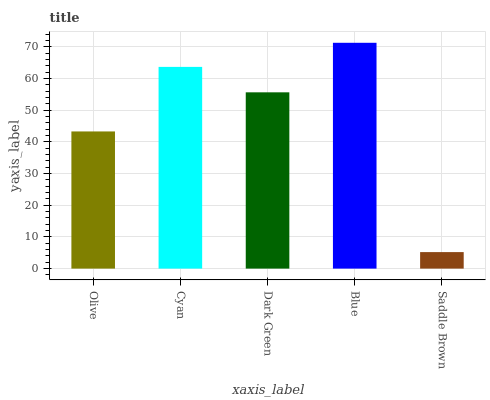Is Saddle Brown the minimum?
Answer yes or no. Yes. Is Blue the maximum?
Answer yes or no. Yes. Is Cyan the minimum?
Answer yes or no. No. Is Cyan the maximum?
Answer yes or no. No. Is Cyan greater than Olive?
Answer yes or no. Yes. Is Olive less than Cyan?
Answer yes or no. Yes. Is Olive greater than Cyan?
Answer yes or no. No. Is Cyan less than Olive?
Answer yes or no. No. Is Dark Green the high median?
Answer yes or no. Yes. Is Dark Green the low median?
Answer yes or no. Yes. Is Olive the high median?
Answer yes or no. No. Is Cyan the low median?
Answer yes or no. No. 